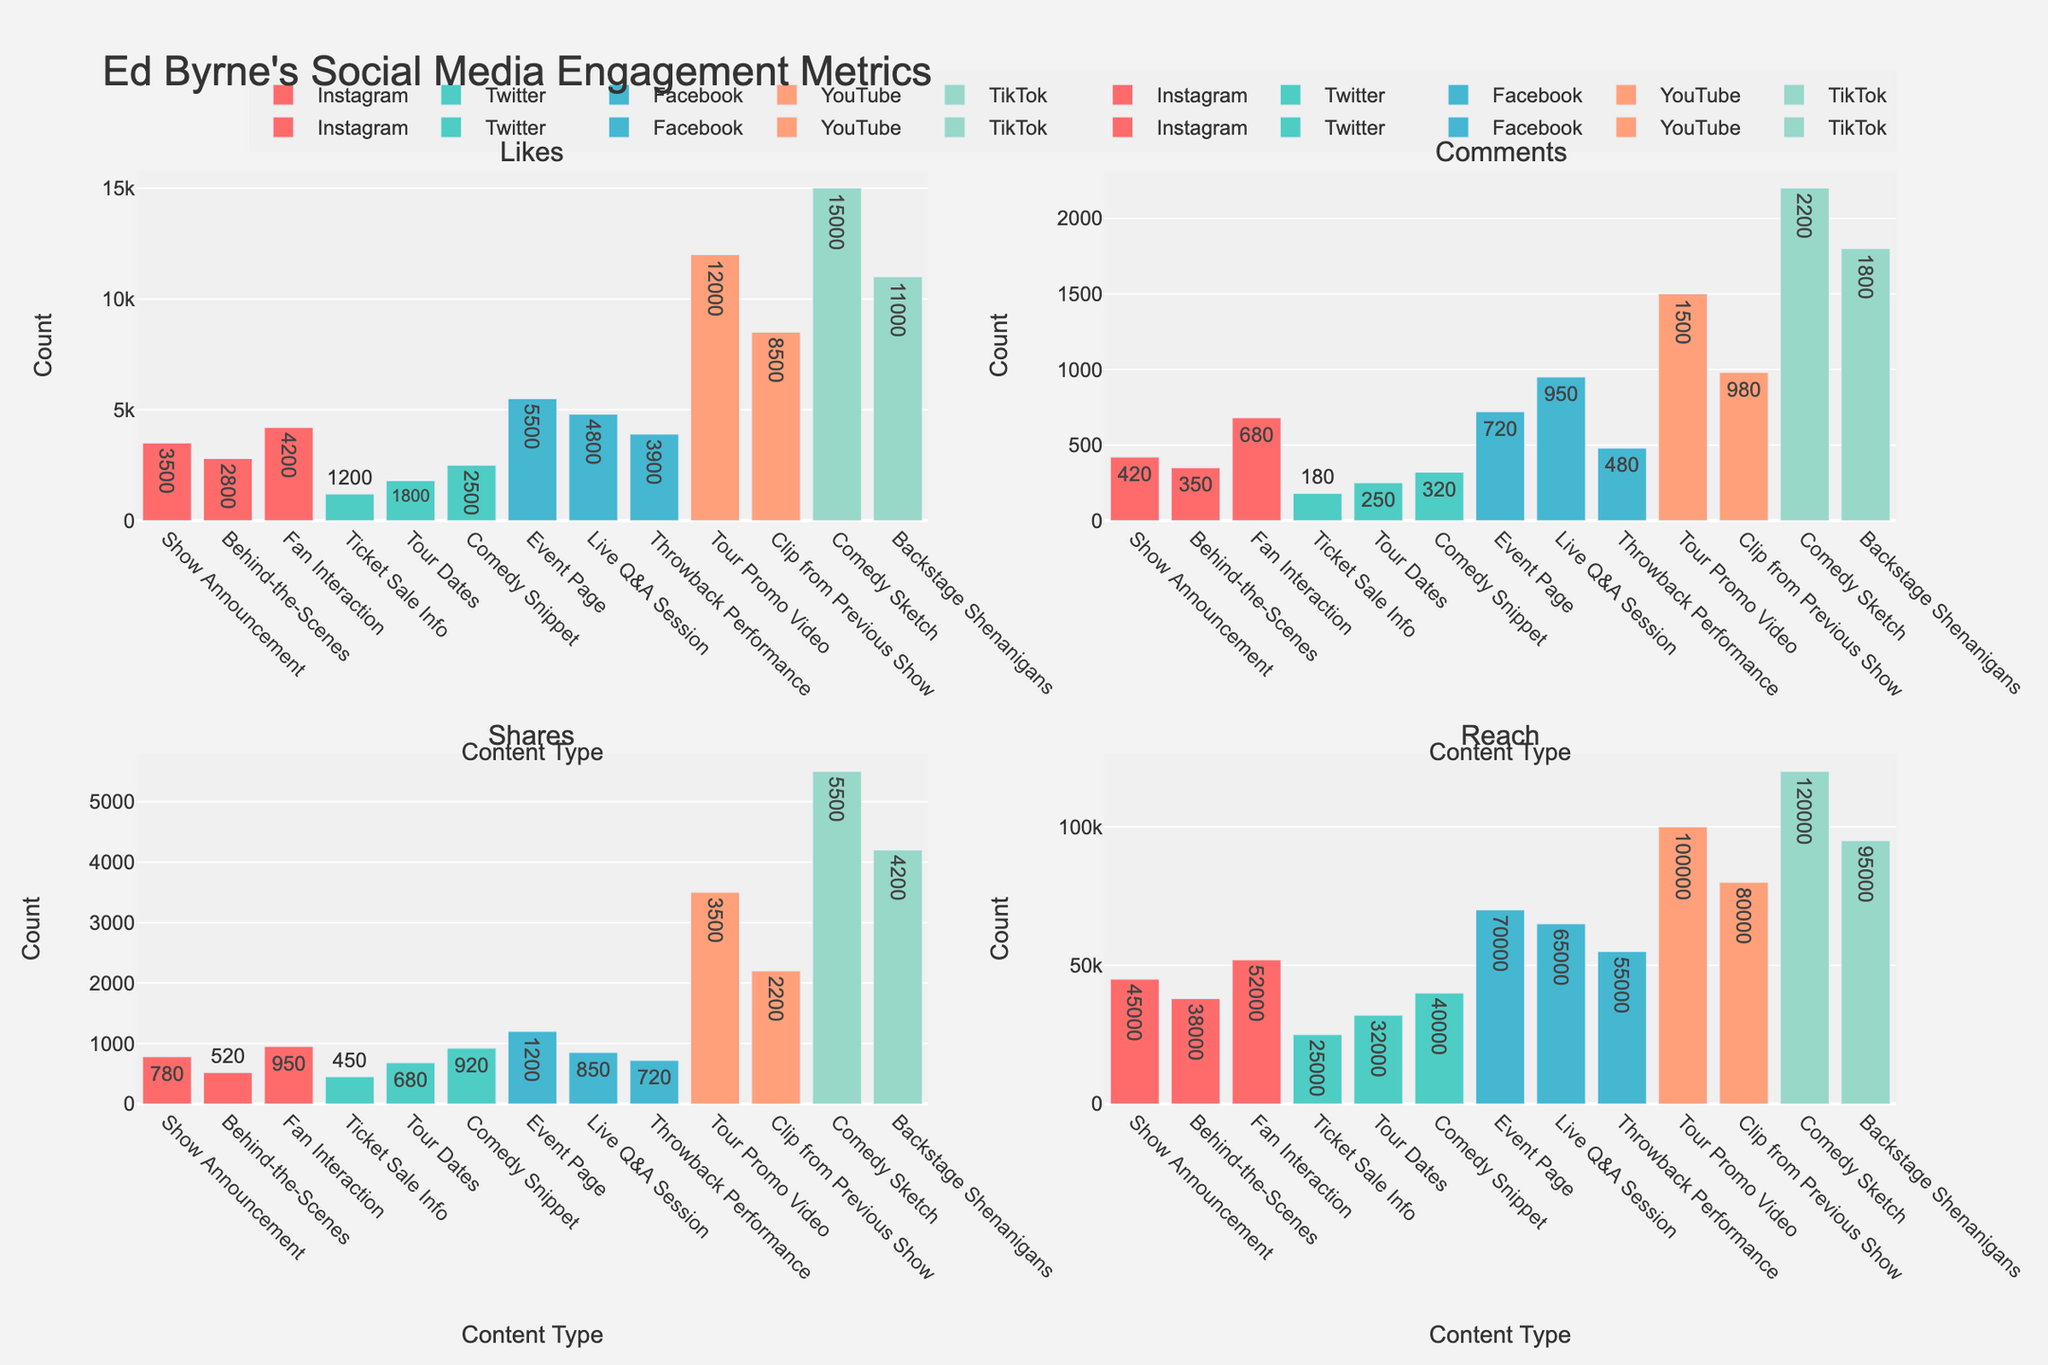Which platform has the highest overall number of likes? By looking at the Likes subplot, you can see that TikTok has the highest value for the "Comedy Sketch" content type, which surpasses Likes from all other platforms.
Answer: TikTok Which content type on Instagram gets the most shares? In the Shares subplot, the highest bar for Instagram is for "Fan Interaction" content type.
Answer: Fan Interaction Which content type on Facebook has the same number of shares as the comedy snippet on Twitter? In the Shares subplot, the "Comedy Snippet" on Twitter has 920 shares. On Facebook, the "Throwback Performance" also has 920 shares.
Answer: Throwback Performance What is the average reach of content types on YouTube? Adding the reach numbers for YouTube content types (Tour Promo Video: 100,000 and Clip from Previous Show: 80,000), divide by 2 for the average. (100,000 + 80,000) / 2 = 90,000
Answer: 90,000 Which content type on TikTok gets the most comments? In the Comments subplot, the highest bar for TikTok is for "Comedy Sketch" content type with 2200 comments.
Answer: Comedy Sketch How does the reach of TikTok’s "Backstage Shenanigans" compare to Facebook’s "Event Page"? By comparing the Reach subplot, "Backstage Shenanigans" on TikTok has 95,000 reach whereas "Event Page" on Facebook has 70,000. TikTok's reach is higher.
Answer: TikTok’s "Backstage Shenanigans" has more reach What is the difference in Likes between Instagram’s "Show Announcement" and "Fan Interaction"? In the Likes subplot, "Show Announcement" has 3,500 likes and "Fan Interaction" has 4,200 likes. The difference is 4,200 - 3,500 = 700.
Answer: 700 Which platform has the most number of comments overall? Summing up all the comments for each platform in the Comments subplot, TikTok has the highest total number of comments.
Answer: TikTok What type of content results in the highest reach on Facebook? In the Reach subplot, the content type "Event Page" on Facebook has the highest reach.
Answer: Event Page Which platform shows the highest engagement (likes, comments, shares, reach) for the content type "Live Q&A Session"? The subplot grid indicates that Facebook shows the highest engagement metrics across all dimensions for "Live Q&A Session".
Answer: Facebook 